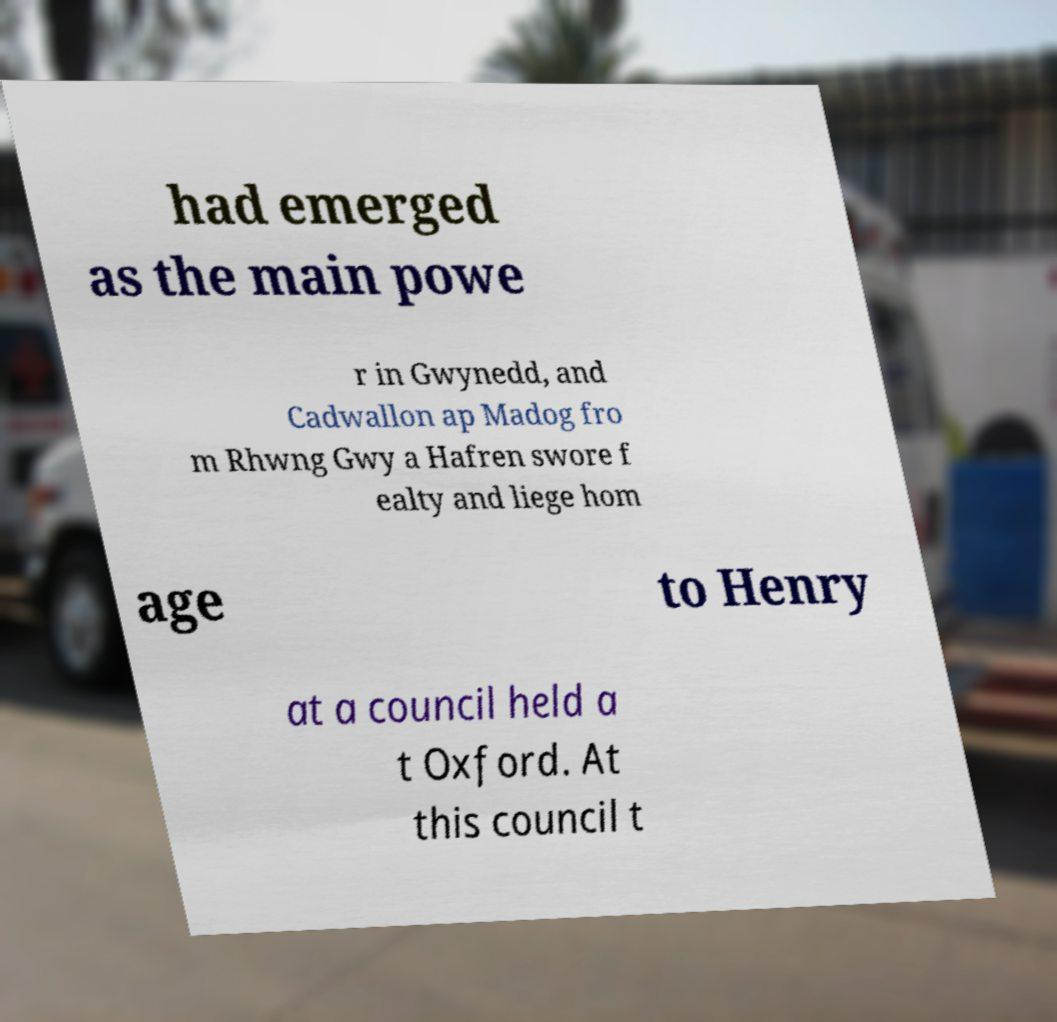Could you assist in decoding the text presented in this image and type it out clearly? had emerged as the main powe r in Gwynedd, and Cadwallon ap Madog fro m Rhwng Gwy a Hafren swore f ealty and liege hom age to Henry at a council held a t Oxford. At this council t 